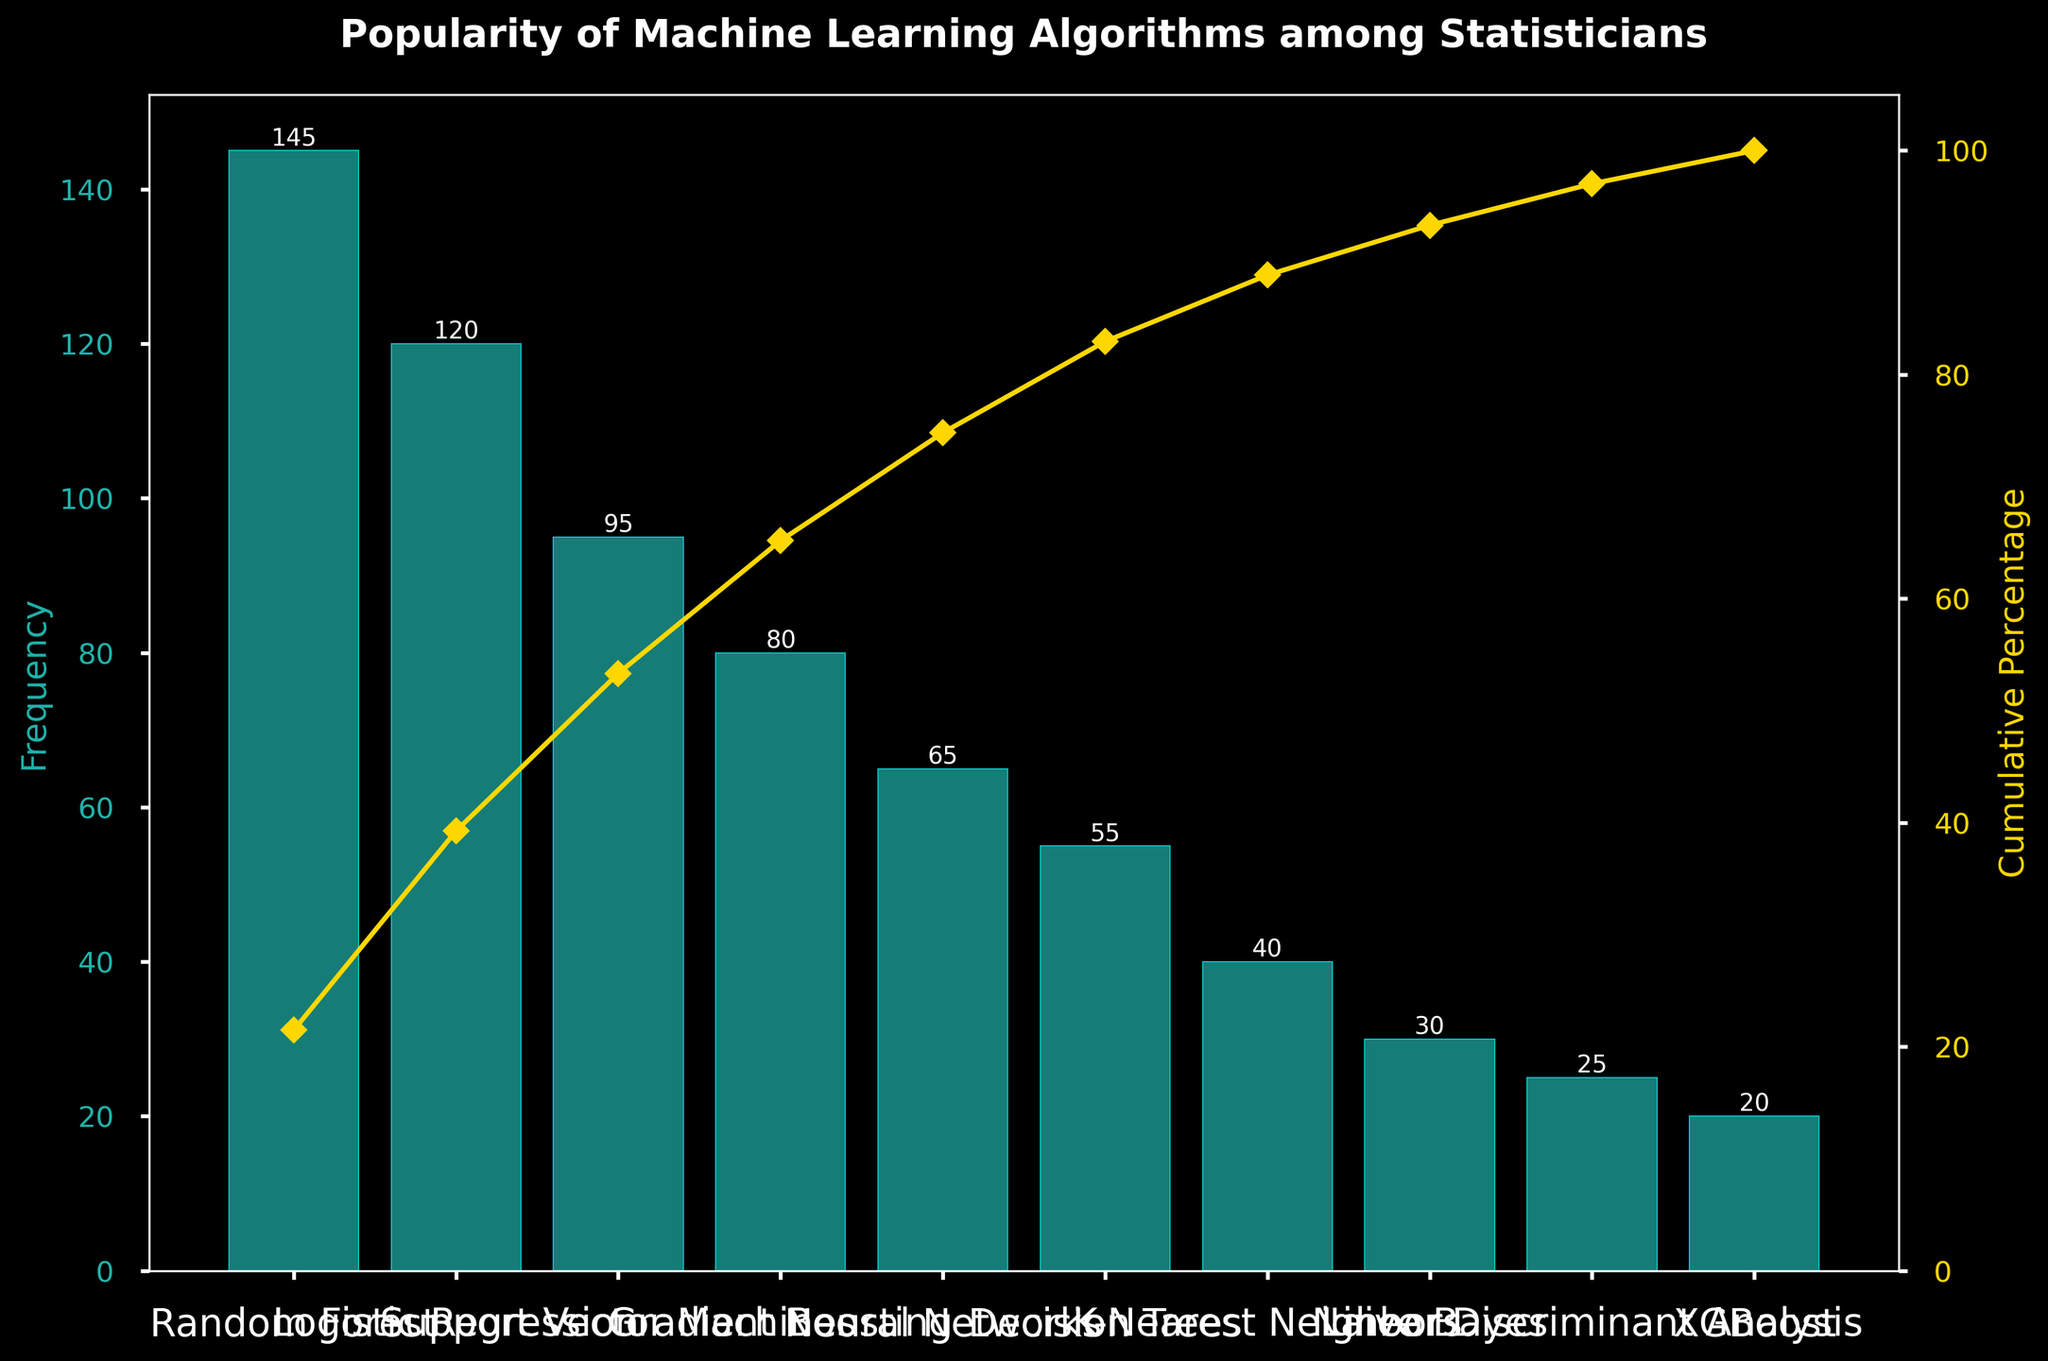What is the title of the chart? The title is found at the top of the chart, displayed in a larger and bold font to clearly indicate the subject of the figure.
Answer: Popularity of Machine Learning Algorithms among Statisticians Which algorithm has the highest frequency? The algorithm with the highest frequency will have the tallest bar in the chart.
Answer: Random Forest What percentage of the total frequency does Logistic Regression and Random Forest combined represent? First find individual frequencies: Random Forest (145) and Logistic Regression (120). Sum these frequencies (145 + 120 = 265). Calculate the percentage by dividing by total frequency (675) and multiplying by 100. This is (265/675)*100.
Answer: 39.26% At what percentage does the cumulative percentage curve first reach above 50%? Look at the cumulative percentage points marked by the curve. Identify the percentage value just above 50%.
Answer: After Support Vector Machines Which algorithm has the lowest frequency? The algorithm with the lowest frequency will have the shortest bar in the chart.
Answer: XGBoost What is the cumulative percentage after 5 algorithms? Add frequencies of the top 5 algorithms: 145 (RF) + 120 (LR) + 95 (SVM) + 80 (GB) + 65 (NN) = 505. Calculate percentage (505/675)*100.
Answer: 74.81% How does the cumulative frequency curve and bars relate visually? Explain that the bars represent individual frequencies, while the curve represents the cumulative percentage, which increases as you move right across the algorithms.
Answer: Bars show individual counts; curve shows accumulating total Are there any algorithms with a frequency below 50? If so, list them. Identify bars with heights below 50 units. These are frequencies for Decision Trees, K-Nearest Neighbors, Naive Bayes, Linear Discriminant Analysis, and XGBoost.
Answer: Decision Trees, K-Nearest Neighbors, Naive Bayes, Linear Discriminant Analysis, XGBoost What is the difference in frequency between Decision Trees and K-Nearest Neighbors? Identify individual frequencies: Decision Trees (55) and K-Nearest Neighbors (40). Subtract to find the difference (55 - 40).
Answer: 15 